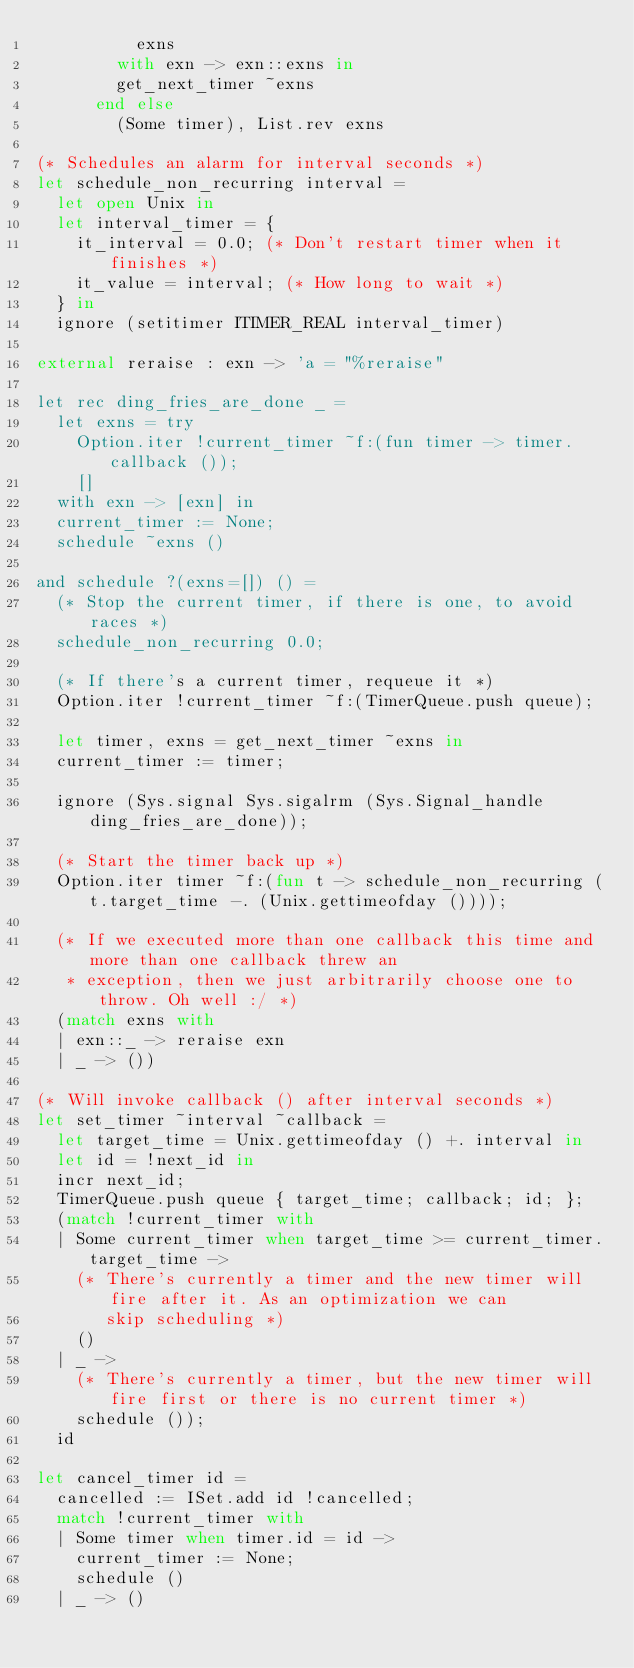Convert code to text. <code><loc_0><loc_0><loc_500><loc_500><_OCaml_>          exns
        with exn -> exn::exns in
        get_next_timer ~exns
      end else
        (Some timer), List.rev exns

(* Schedules an alarm for interval seconds *)
let schedule_non_recurring interval =
  let open Unix in
  let interval_timer = {
    it_interval = 0.0; (* Don't restart timer when it finishes *)
    it_value = interval; (* How long to wait *)
  } in
  ignore (setitimer ITIMER_REAL interval_timer)

external reraise : exn -> 'a = "%reraise"

let rec ding_fries_are_done _ =
  let exns = try
    Option.iter !current_timer ~f:(fun timer -> timer.callback ());
    []
  with exn -> [exn] in
  current_timer := None;
  schedule ~exns ()

and schedule ?(exns=[]) () =
  (* Stop the current timer, if there is one, to avoid races *)
  schedule_non_recurring 0.0;

  (* If there's a current timer, requeue it *)
  Option.iter !current_timer ~f:(TimerQueue.push queue);

  let timer, exns = get_next_timer ~exns in
  current_timer := timer;

  ignore (Sys.signal Sys.sigalrm (Sys.Signal_handle ding_fries_are_done));

  (* Start the timer back up *)
  Option.iter timer ~f:(fun t -> schedule_non_recurring (t.target_time -. (Unix.gettimeofday ())));

  (* If we executed more than one callback this time and more than one callback threw an
   * exception, then we just arbitrarily choose one to throw. Oh well :/ *)
  (match exns with
  | exn::_ -> reraise exn
  | _ -> ())

(* Will invoke callback () after interval seconds *)
let set_timer ~interval ~callback =
  let target_time = Unix.gettimeofday () +. interval in
  let id = !next_id in
  incr next_id;
  TimerQueue.push queue { target_time; callback; id; };
  (match !current_timer with
  | Some current_timer when target_time >= current_timer.target_time ->
    (* There's currently a timer and the new timer will fire after it. As an optimization we can
       skip scheduling *)
    ()
  | _ ->
    (* There's currently a timer, but the new timer will fire first or there is no current timer *)
    schedule ());
  id

let cancel_timer id =
  cancelled := ISet.add id !cancelled;
  match !current_timer with
  | Some timer when timer.id = id ->
    current_timer := None;
    schedule ()
  | _ -> ()
</code> 